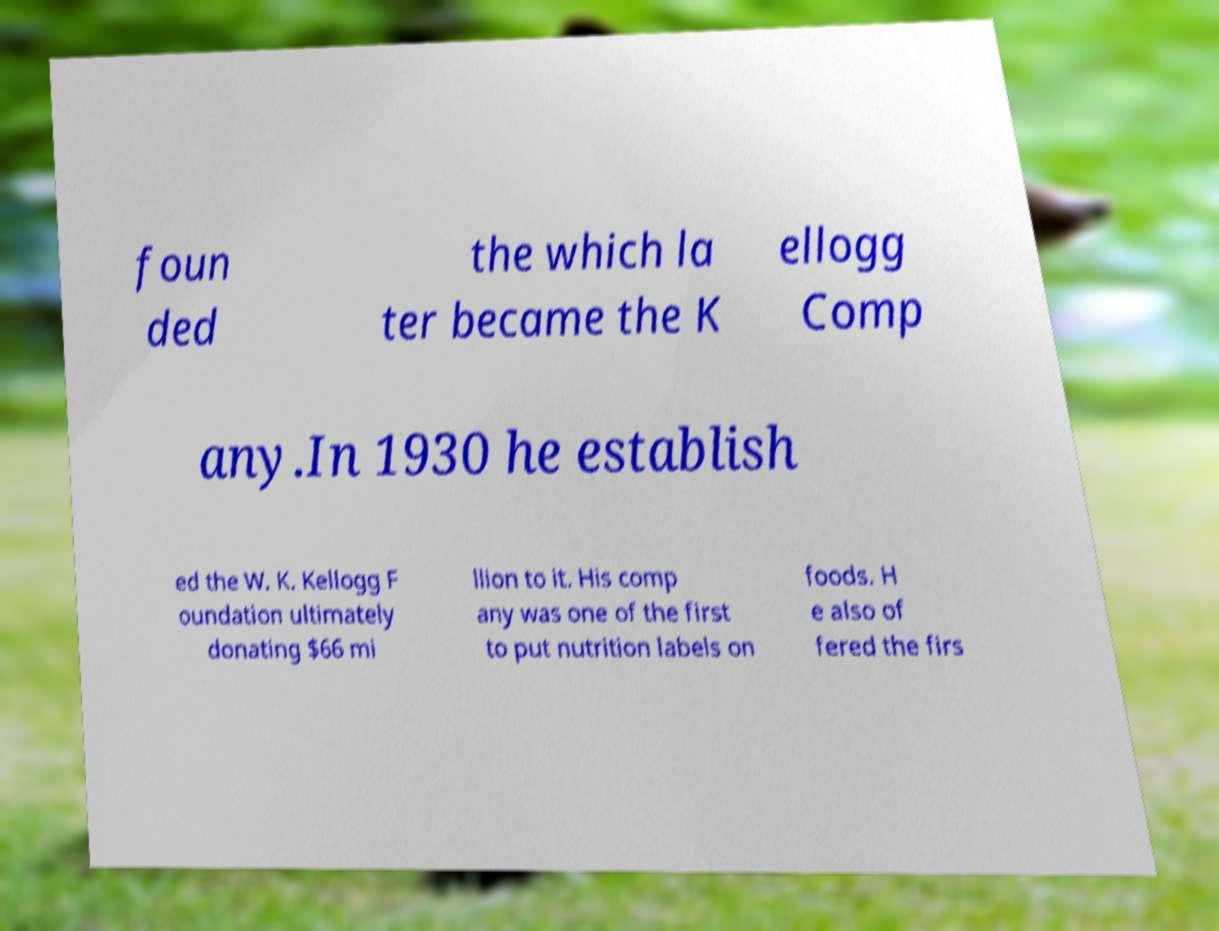What messages or text are displayed in this image? I need them in a readable, typed format. foun ded the which la ter became the K ellogg Comp any.In 1930 he establish ed the W. K. Kellogg F oundation ultimately donating $66 mi llion to it. His comp any was one of the first to put nutrition labels on foods. H e also of fered the firs 